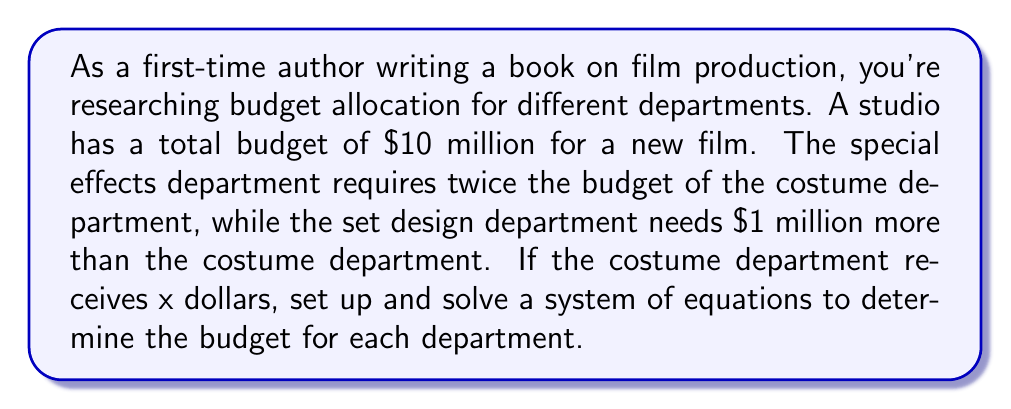Give your solution to this math problem. Let's define our variables:
$x$ = budget for costume department
$2x$ = budget for special effects department
$x + 1,000,000$ = budget for set design department

Step 1: Set up the equation based on the total budget
$$x + 2x + (x + 1,000,000) = 10,000,000$$

Step 2: Simplify the left side of the equation
$$4x + 1,000,000 = 10,000,000$$

Step 3: Subtract 1,000,000 from both sides
$$4x = 9,000,000$$

Step 4: Divide both sides by 4
$$x = 2,250,000$$

Step 5: Calculate the budget for each department
Costume department: $x = 2,250,000$
Special effects department: $2x = 2(2,250,000) = 4,500,000$
Set design department: $x + 1,000,000 = 2,250,000 + 1,000,000 = 3,250,000$

Step 6: Verify that the total budget adds up to $10 million
$$2,250,000 + 4,500,000 + 3,250,000 = 10,000,000$$
Answer: Costume: $2,250,000, Special Effects: $4,500,000, Set Design: $3,250,000 